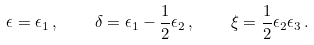<formula> <loc_0><loc_0><loc_500><loc_500>\epsilon = \epsilon _ { 1 } \, , \quad \delta = \epsilon _ { 1 } - \frac { 1 } { 2 } \epsilon _ { 2 } \, , \quad \xi = \frac { 1 } { 2 } \epsilon _ { 2 } \epsilon _ { 3 } \, .</formula> 